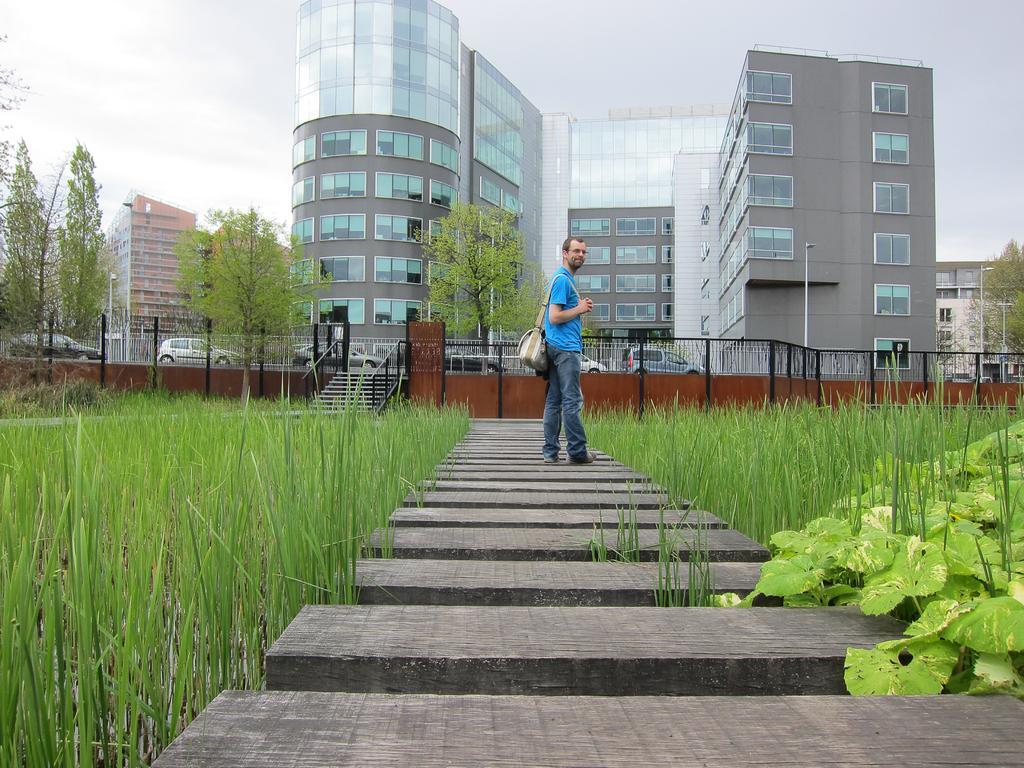In one or two sentences, can you explain what this image depicts? In this image we can see a man standing on the walkway bridge, agricultural field, creeper plants, staircase, railings, motor vehicles on the road, buildings, street poles, street lights, trees and sky. 